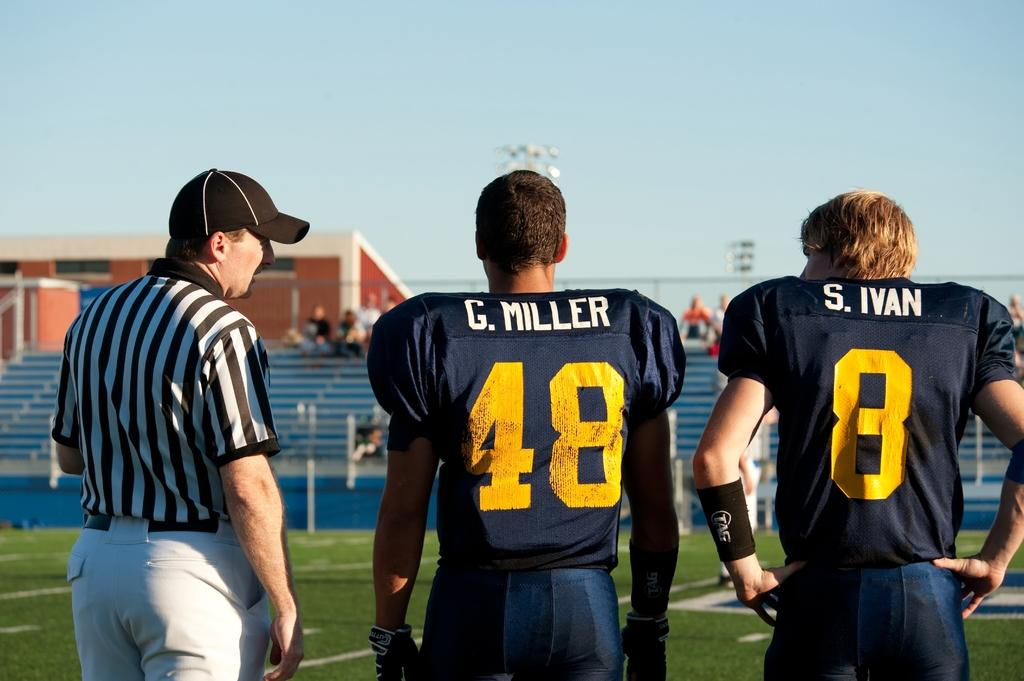<image>
Summarize the visual content of the image. A referee talks to Miller and Ivan on the side of the field. 